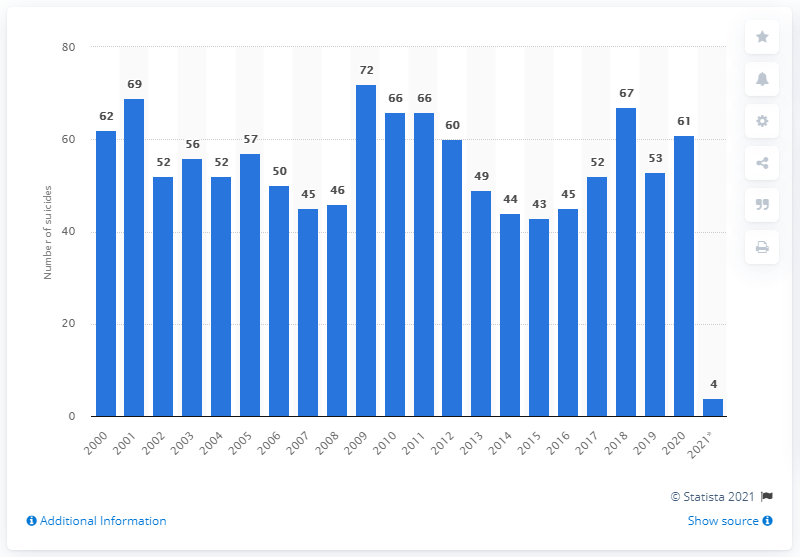Point out several critical features in this image. During the period of 2000 to 2020 in Italy, a record number of 72 prisoners committed suicide. 